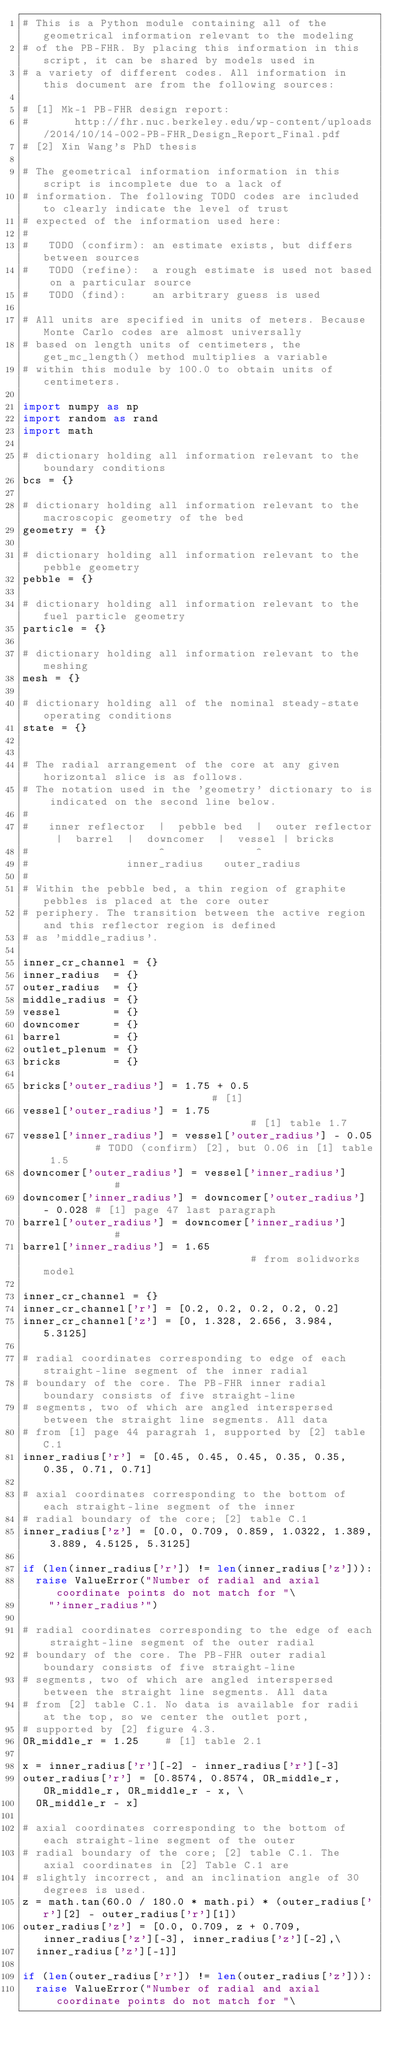Convert code to text. <code><loc_0><loc_0><loc_500><loc_500><_Python_># This is a Python module containing all of the geometrical information relevant to the modeling
# of the PB-FHR. By placing this information in this script, it can be shared by models used in
# a variety of different codes. All information in this document are from the following sources:

# [1] Mk-1 PB-FHR design report:
#       http://fhr.nuc.berkeley.edu/wp-content/uploads/2014/10/14-002-PB-FHR_Design_Report_Final.pdf
# [2] Xin Wang's PhD thesis

# The geometrical information information in this script is incomplete due to a lack of
# information. The following TODO codes are included to clearly indicate the level of trust
# expected of the information used here:
#
#   TODO (confirm): an estimate exists, but differs between sources
#   TODO (refine):  a rough estimate is used not based on a particular source
#   TODO (find):    an arbitrary guess is used

# All units are specified in units of meters. Because Monte Carlo codes are almost universally
# based on length units of centimeters, the get_mc_length() method multiplies a variable
# within this module by 100.0 to obtain units of centimeters.

import numpy as np
import random as rand
import math

# dictionary holding all information relevant to the boundary conditions
bcs = {}

# dictionary holding all information relevant to the macroscopic geometry of the bed
geometry = {}

# dictionary holding all information relevant to the pebble geometry
pebble = {}

# dictionary holding all information relevant to the fuel particle geometry
particle = {}

# dictionary holding all information relevant to the meshing
mesh = {}

# dictionary holding all of the nominal steady-state operating conditions
state = {}


# The radial arrangement of the core at any given horizontal slice is as follows.
# The notation used in the 'geometry' dictionary to is indicated on the second line below.
#
#   inner reflector  |  pebble bed  |  outer reflector  |  barrel  |  downcomer  |  vessel | bricks
#                    ^              ^
#               inner_radius   outer_radius
#
# Within the pebble bed, a thin region of graphite pebbles is placed at the core outer
# periphery. The transition between the active region and this reflector region is defined
# as 'middle_radius'.

inner_cr_channel = {}
inner_radius  = {}
outer_radius  = {}
middle_radius = {}
vessel        = {}
downcomer     = {}
barrel        = {}
outlet_plenum = {}
bricks        = {}

bricks['outer_radius'] = 1.75 + 0.5                           # [1]
vessel['outer_radius'] = 1.75                                 # [1] table 1.7
vessel['inner_radius'] = vessel['outer_radius'] - 0.05        # TODO (confirm) [2], but 0.06 in [1] table 1.5
downcomer['outer_radius'] = vessel['inner_radius']            #
downcomer['inner_radius'] = downcomer['outer_radius'] - 0.028 # [1] page 47 last paragraph
barrel['outer_radius'] = downcomer['inner_radius']            #
barrel['inner_radius'] = 1.65                                 # from solidworks model

inner_cr_channel = {}
inner_cr_channel['r'] = [0.2, 0.2, 0.2, 0.2, 0.2]
inner_cr_channel['z'] = [0, 1.328, 2.656, 3.984, 5.3125]

# radial coordinates corresponding to edge of each straight-line segment of the inner radial
# boundary of the core. The PB-FHR inner radial boundary consists of five straight-line
# segments, two of which are angled interspersed between the straight line segments. All data
# from [1] page 44 paragrah 1, supported by [2] table C.1
inner_radius['r'] = [0.45, 0.45, 0.45, 0.35, 0.35, 0.35, 0.71, 0.71]

# axial coordinates corresponding to the bottom of each straight-line segment of the inner
# radial boundary of the core; [2] table C.1
inner_radius['z'] = [0.0, 0.709, 0.859, 1.0322, 1.389, 3.889, 4.5125, 5.3125]

if (len(inner_radius['r']) != len(inner_radius['z'])):
  raise ValueError("Number of radial and axial coordinate points do not match for "\
    "'inner_radius'")

# radial coordinates corresponding to the edge of each straight-line segment of the outer radial
# boundary of the core. The PB-FHR outer radial boundary consists of five straight-line
# segments, two of which are angled interspersed between the straight line segments. All data
# from [2] table C.1. No data is available for radii at the top, so we center the outlet port,
# supported by [2] figure 4.3.
OR_middle_r = 1.25    # [1] table 2.1

x = inner_radius['r'][-2] - inner_radius['r'][-3]
outer_radius['r'] = [0.8574, 0.8574, OR_middle_r, OR_middle_r, OR_middle_r - x, \
  OR_middle_r - x]

# axial coordinates corresponding to the bottom of each straight-line segment of the outer
# radial boundary of the core; [2] table C.1. The axial coordinates in [2] Table C.1 are
# slightly incorrect, and an inclination angle of 30 degrees is used.
z = math.tan(60.0 / 180.0 * math.pi) * (outer_radius['r'][2] - outer_radius['r'][1])
outer_radius['z'] = [0.0, 0.709, z + 0.709, inner_radius['z'][-3], inner_radius['z'][-2],\
  inner_radius['z'][-1]]

if (len(outer_radius['r']) != len(outer_radius['z'])):
  raise ValueError("Number of radial and axial coordinate points do not match for "\</code> 